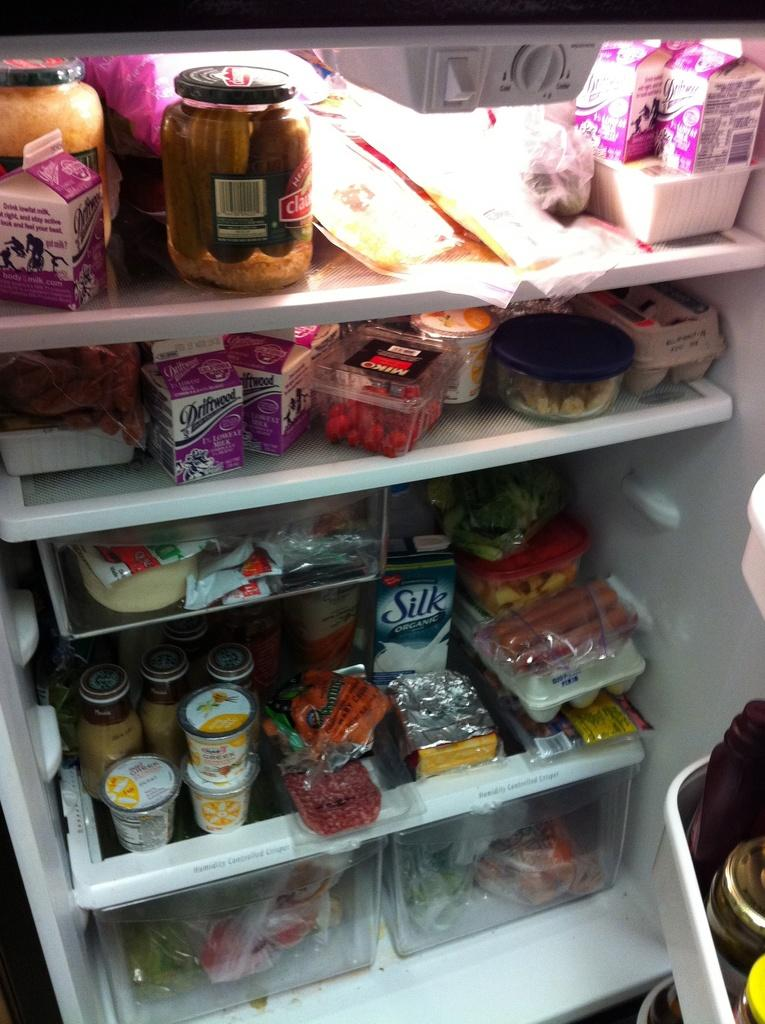<image>
Write a terse but informative summary of the picture. A carton of Silk Organic Milk sits on the bottom shelf of a messy refrigerator 